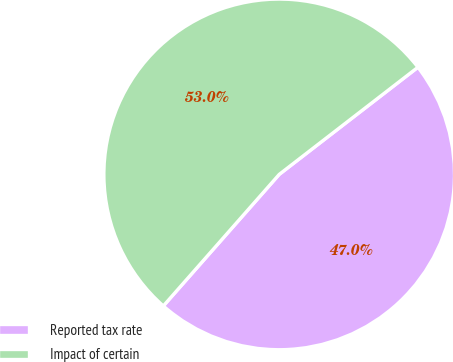Convert chart to OTSL. <chart><loc_0><loc_0><loc_500><loc_500><pie_chart><fcel>Reported tax rate<fcel>Impact of certain<nl><fcel>46.96%<fcel>53.04%<nl></chart> 